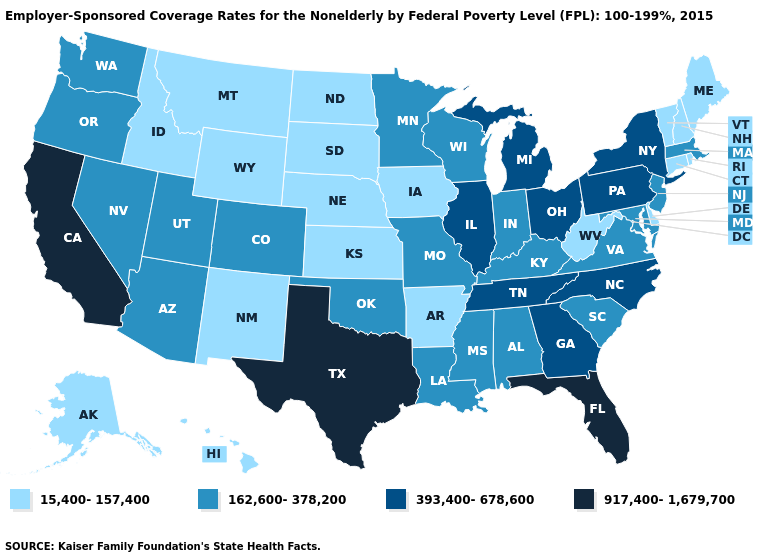Among the states that border Minnesota , which have the highest value?
Be succinct. Wisconsin. Among the states that border Utah , which have the lowest value?
Short answer required. Idaho, New Mexico, Wyoming. Among the states that border Wyoming , does Idaho have the highest value?
Keep it brief. No. What is the highest value in states that border Michigan?
Concise answer only. 393,400-678,600. What is the value of Washington?
Keep it brief. 162,600-378,200. Name the states that have a value in the range 917,400-1,679,700?
Write a very short answer. California, Florida, Texas. Does Vermont have the highest value in the Northeast?
Be succinct. No. Name the states that have a value in the range 917,400-1,679,700?
Give a very brief answer. California, Florida, Texas. What is the value of Rhode Island?
Be succinct. 15,400-157,400. Among the states that border Kansas , does Nebraska have the lowest value?
Quick response, please. Yes. What is the value of Washington?
Short answer required. 162,600-378,200. What is the value of Wisconsin?
Quick response, please. 162,600-378,200. What is the value of Tennessee?
Give a very brief answer. 393,400-678,600. Is the legend a continuous bar?
Be succinct. No. Among the states that border Vermont , which have the highest value?
Answer briefly. New York. 